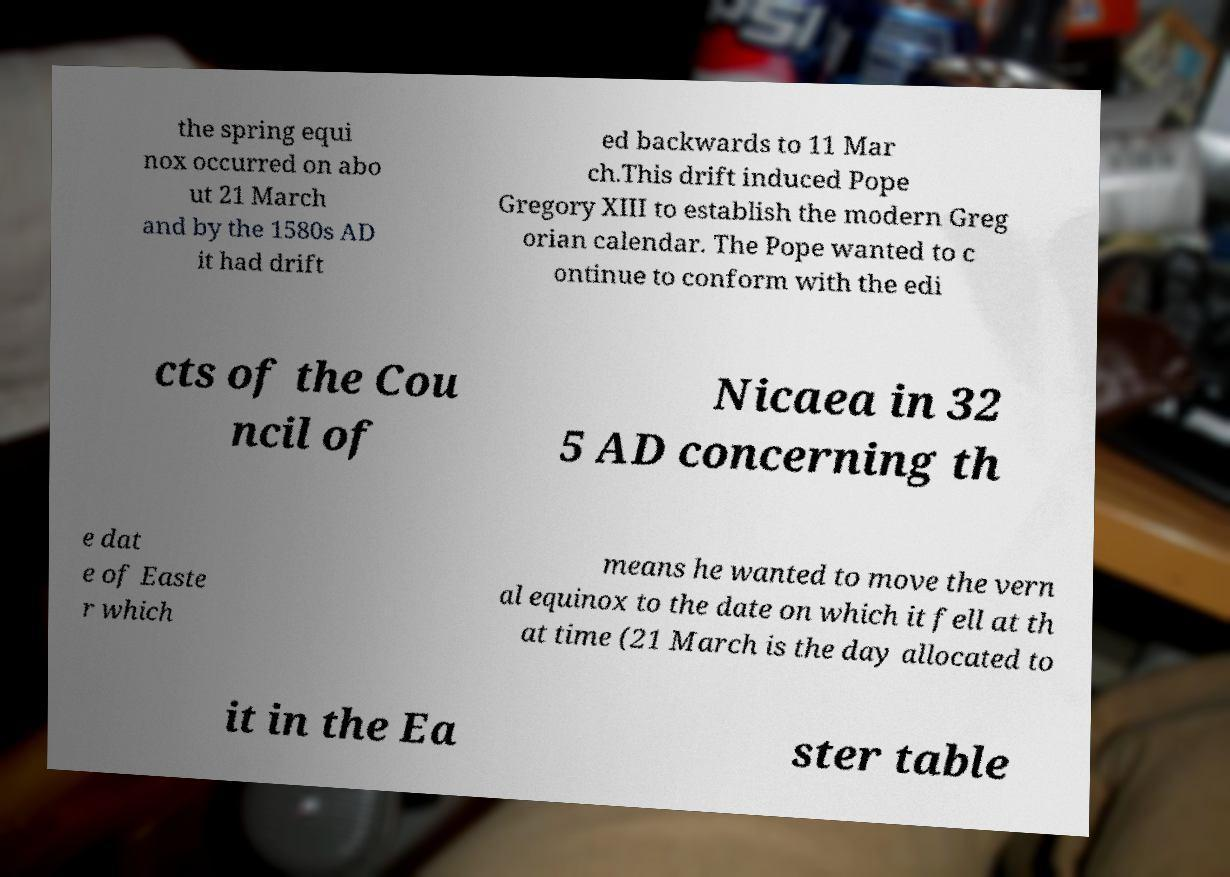Could you extract and type out the text from this image? the spring equi nox occurred on abo ut 21 March and by the 1580s AD it had drift ed backwards to 11 Mar ch.This drift induced Pope Gregory XIII to establish the modern Greg orian calendar. The Pope wanted to c ontinue to conform with the edi cts of the Cou ncil of Nicaea in 32 5 AD concerning th e dat e of Easte r which means he wanted to move the vern al equinox to the date on which it fell at th at time (21 March is the day allocated to it in the Ea ster table 